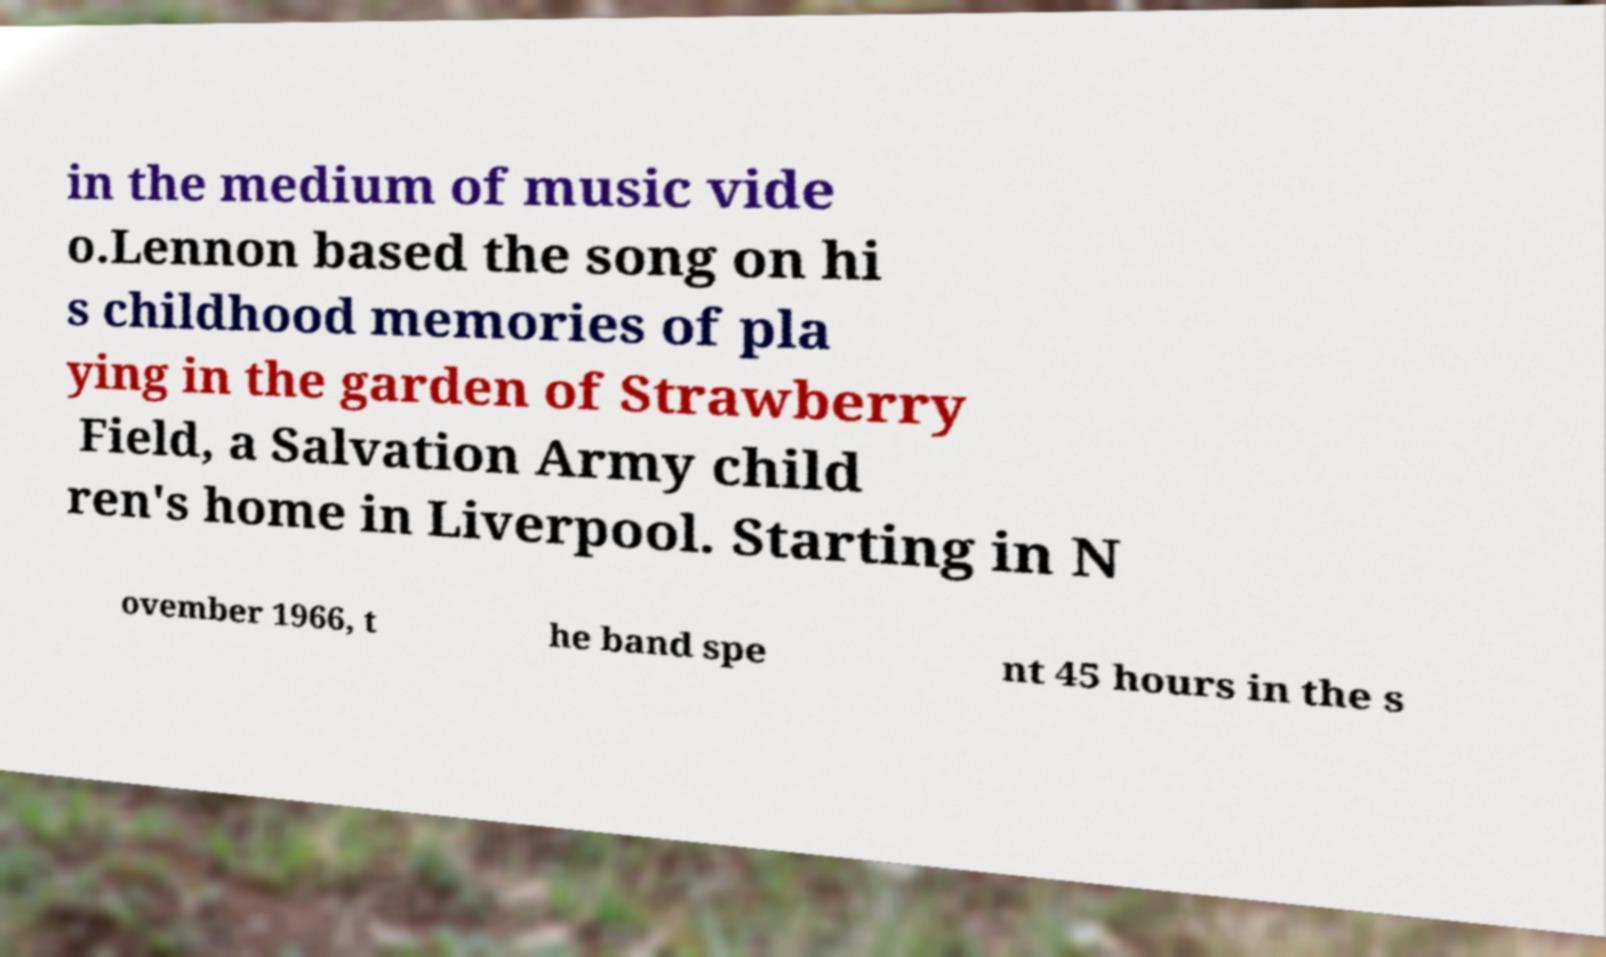Could you extract and type out the text from this image? in the medium of music vide o.Lennon based the song on hi s childhood memories of pla ying in the garden of Strawberry Field, a Salvation Army child ren's home in Liverpool. Starting in N ovember 1966, t he band spe nt 45 hours in the s 